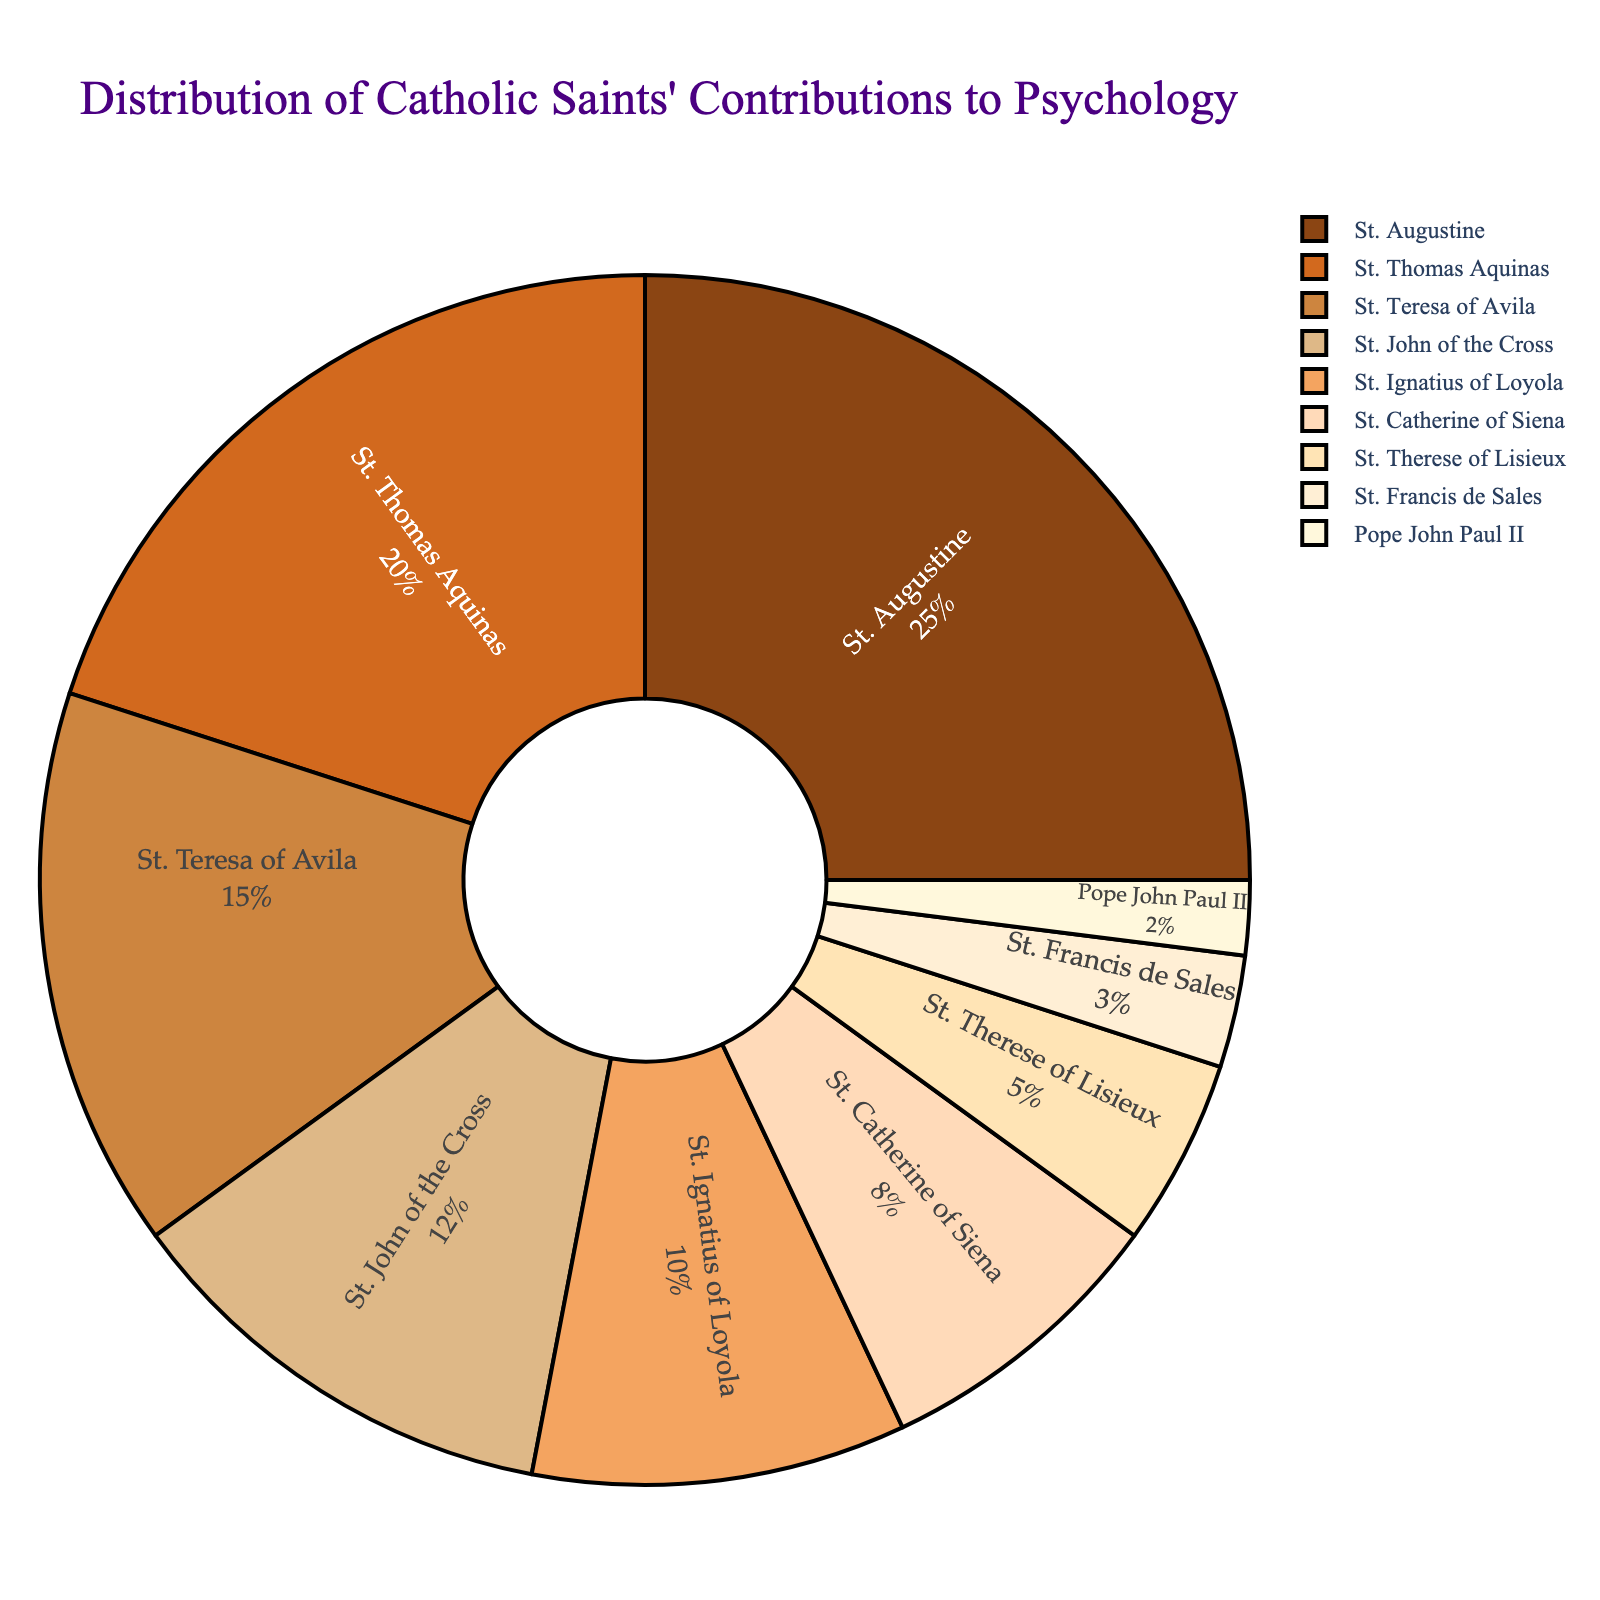what percentage of contributions to psychology is attributed to the two saints with the highest contributions? St. Augustine contributes 25% and St. Thomas Aquinas contributes 20%. Adding these percentages together, 25% + 20% = 45%.
Answer: 45% do St. Teresa of Avila and St. John of the Cross together contribute more than St. Augustine alone? St. Teresa of Avila contributes 15% and St. John of the Cross contributes 12%. Adding these together, 15% + 12% = 27%, which is less than St. Augustine's 25%.
Answer: No which saint has the smallest contribution to psychology? Among the listed saints, Pope John Paul II has the smallest percentage at 2%.
Answer: Pope John Paul II what is the combined contribution percentage of saints starting with 'St. T'? The saints are St. Teresa of Avila (15%), St. Therese of Lisieux (5%), and St. Thomas Aquinas (20%). Adding these together, 15% + 5% + 20% = 40%.
Answer: 40% how much larger is St. Augustine's contribution compared to St. Francis de Sales? St. Augustine contributes 25% and St. Francis de Sales contributes 3%. The difference is 25% - 3% = 22%.
Answer: 22% which two saints have contributions that sum to 28%? St. John of the Cross contributes 12% and St. Ignatius of Loyola contributes 10%. Together, their contributions are 12% + 10% = 22%. However, St. John of the Cross (12%) and St. Catherine of Siena (8%) add up to 20%. Finally, St. Teresa of Avila (15%) and St. John of the Cross (12%), add up to 28%.
Answer: St. Teresa of Avila and St. John of the Cross what is the color used to represent St. Ignatius of Loyola in the pie chart? The color for St. Ignatius of Loyola is the fifth color in the provided marker colors, which is "#F4A460" or light orange.
Answer: Light Orange how does the contribution of St. Catherine of Siena compare to that of St. Therese of Lisieux? St. Catherine of Siena's contribution is 8%, while St. Therese of Lisieux's contribution is 5%. Thus, St. Catherine of Siena's contribution is 3% higher than St. Therese of Lisieux's.
Answer: St. Catherine of Siena's contribution is 3% higher list all saints whose contribution is less than 10%. The saints with contributions less than 10% are St. Catherine of Siena (8%), St. Therese of Lisieux (5%), St. Francis de Sales (3%), and Pope John Paul II (2%).
Answer: St. Catherine of Siena, St. Therese of Lisieux, St. Francis de Sales, Pope John Paul II what percentage of the total contribution do the saints with contributions between 5% and 15% inclusive make up? St. Teresa of Avila (15%), St. John of the Cross (12%), St. Ignatius of Loyola (10%), and St. Therese of Lisieux (5%) fall within this range. Adding their contributions: 15% + 12% + 10% + 5% = 42%.
Answer: 42% 